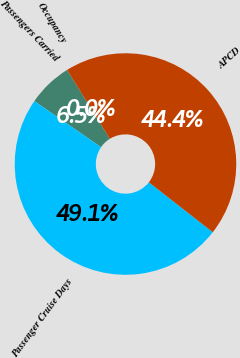Convert chart. <chart><loc_0><loc_0><loc_500><loc_500><pie_chart><fcel>Passengers Carried<fcel>Passenger Cruise Days<fcel>APCD<fcel>Occupancy<nl><fcel>6.54%<fcel>49.06%<fcel>44.39%<fcel>0.0%<nl></chart> 